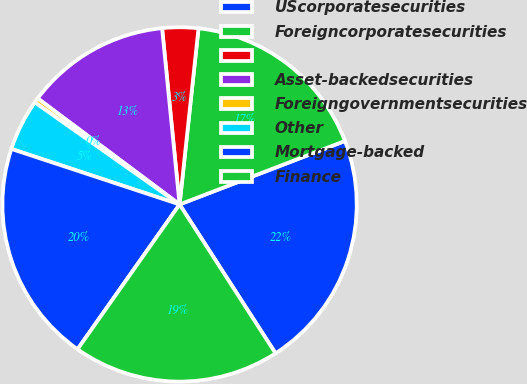<chart> <loc_0><loc_0><loc_500><loc_500><pie_chart><fcel>UScorporatesecurities<fcel>Foreigncorporatesecurities<fcel>Unnamed: 2<fcel>Asset-backedsecurities<fcel>Foreigngovernmentsecurities<fcel>Other<fcel>Mortgage-backed<fcel>Finance<nl><fcel>21.72%<fcel>17.46%<fcel>3.28%<fcel>13.21%<fcel>0.44%<fcel>4.7%<fcel>20.3%<fcel>18.88%<nl></chart> 